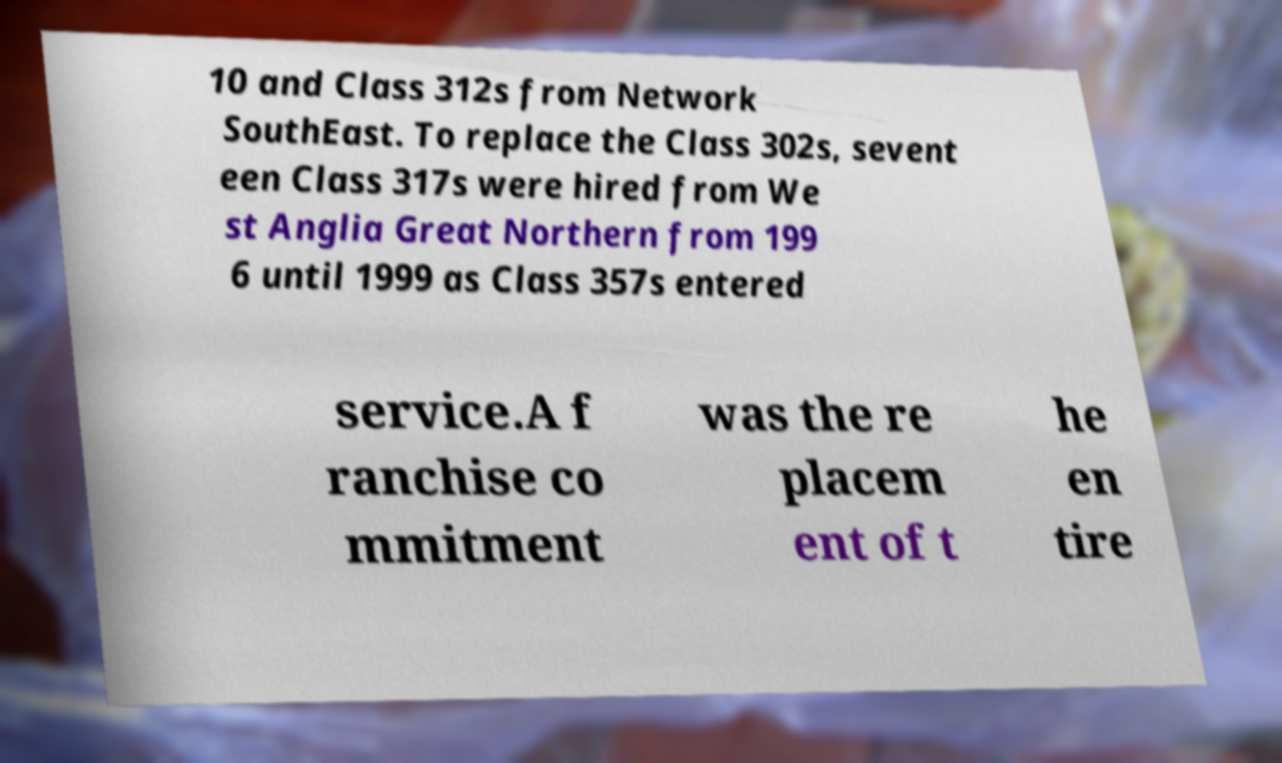I need the written content from this picture converted into text. Can you do that? 10 and Class 312s from Network SouthEast. To replace the Class 302s, sevent een Class 317s were hired from We st Anglia Great Northern from 199 6 until 1999 as Class 357s entered service.A f ranchise co mmitment was the re placem ent of t he en tire 